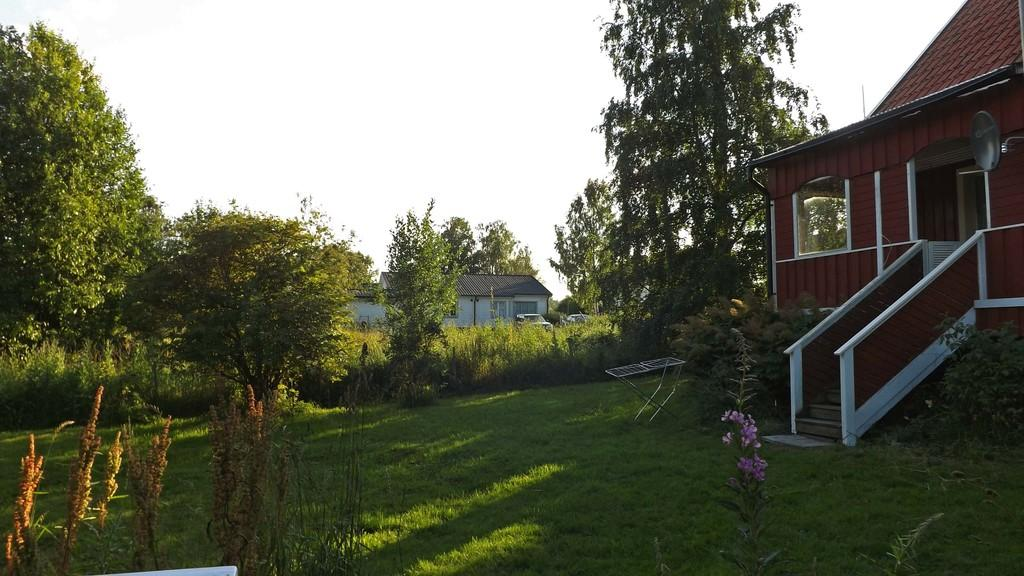What type of vegetation can be seen in the image? There are trees, plants, and grass in the image. What type of structures are present in the image? There are houses in the image. Can you describe any architectural features in the image? There is a staircase in the image. What other natural elements can be seen in the image? There are flowers in the image. What part of the natural environment is visible in the image? The sky is visible in the image. Can you describe any man-made features in the image? There is a window in the image. What shape is the notebook in the image? There is no notebook present in the image. How does the stop sign affect the movement of the cars in the image? There is no stop sign present in the image, so it cannot affect the movement of any cars. 